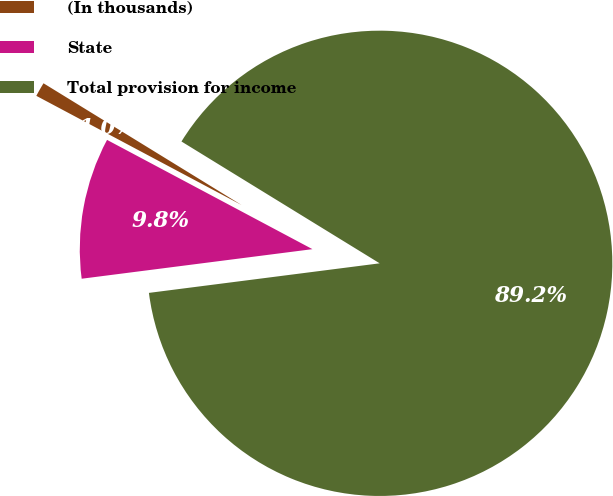Convert chart to OTSL. <chart><loc_0><loc_0><loc_500><loc_500><pie_chart><fcel>(In thousands)<fcel>State<fcel>Total provision for income<nl><fcel>0.99%<fcel>9.81%<fcel>89.2%<nl></chart> 